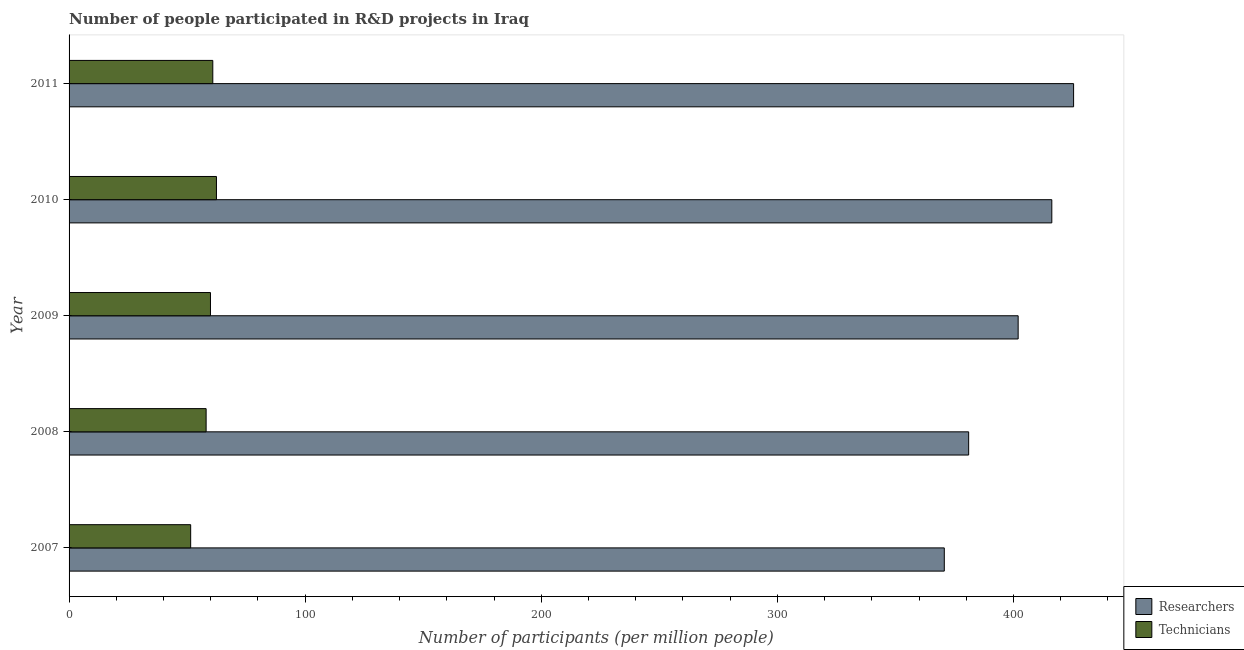How many groups of bars are there?
Provide a succinct answer. 5. How many bars are there on the 5th tick from the bottom?
Your answer should be very brief. 2. In how many cases, is the number of bars for a given year not equal to the number of legend labels?
Make the answer very short. 0. What is the number of researchers in 2009?
Your answer should be compact. 401.99. Across all years, what is the maximum number of researchers?
Your answer should be compact. 425.48. Across all years, what is the minimum number of researchers?
Make the answer very short. 370.71. In which year was the number of researchers maximum?
Provide a succinct answer. 2011. What is the total number of researchers in the graph?
Provide a short and direct response. 1995.47. What is the difference between the number of technicians in 2008 and that in 2010?
Keep it short and to the point. -4.37. What is the difference between the number of technicians in 2011 and the number of researchers in 2010?
Ensure brevity in your answer.  -355.38. What is the average number of technicians per year?
Offer a very short reply. 58.55. In the year 2008, what is the difference between the number of researchers and number of technicians?
Provide a succinct answer. 322.97. In how many years, is the number of researchers greater than 380 ?
Offer a terse response. 4. What is the ratio of the number of technicians in 2007 to that in 2008?
Your response must be concise. 0.89. Is the number of researchers in 2008 less than that in 2011?
Offer a terse response. Yes. Is the difference between the number of researchers in 2008 and 2009 greater than the difference between the number of technicians in 2008 and 2009?
Ensure brevity in your answer.  No. What is the difference between the highest and the second highest number of researchers?
Offer a very short reply. 9.22. What is the difference between the highest and the lowest number of technicians?
Give a very brief answer. 10.92. In how many years, is the number of technicians greater than the average number of technicians taken over all years?
Make the answer very short. 3. What does the 2nd bar from the top in 2009 represents?
Keep it short and to the point. Researchers. What does the 2nd bar from the bottom in 2011 represents?
Provide a succinct answer. Technicians. How many bars are there?
Your answer should be compact. 10. Are all the bars in the graph horizontal?
Offer a very short reply. Yes. What is the difference between two consecutive major ticks on the X-axis?
Your answer should be very brief. 100. Are the values on the major ticks of X-axis written in scientific E-notation?
Your answer should be compact. No. Does the graph contain any zero values?
Provide a succinct answer. No. How many legend labels are there?
Make the answer very short. 2. What is the title of the graph?
Give a very brief answer. Number of people participated in R&D projects in Iraq. Does "RDB concessional" appear as one of the legend labels in the graph?
Provide a succinct answer. No. What is the label or title of the X-axis?
Give a very brief answer. Number of participants (per million people). What is the label or title of the Y-axis?
Make the answer very short. Year. What is the Number of participants (per million people) in Researchers in 2007?
Keep it short and to the point. 370.71. What is the Number of participants (per million people) of Technicians in 2007?
Provide a succinct answer. 51.51. What is the Number of participants (per million people) in Researchers in 2008?
Offer a terse response. 381.03. What is the Number of participants (per million people) in Technicians in 2008?
Provide a short and direct response. 58.05. What is the Number of participants (per million people) of Researchers in 2009?
Your answer should be very brief. 401.99. What is the Number of participants (per million people) in Technicians in 2009?
Make the answer very short. 59.89. What is the Number of participants (per million people) in Researchers in 2010?
Provide a succinct answer. 416.25. What is the Number of participants (per million people) in Technicians in 2010?
Offer a very short reply. 62.43. What is the Number of participants (per million people) in Researchers in 2011?
Keep it short and to the point. 425.48. What is the Number of participants (per million people) in Technicians in 2011?
Provide a short and direct response. 60.88. Across all years, what is the maximum Number of participants (per million people) in Researchers?
Keep it short and to the point. 425.48. Across all years, what is the maximum Number of participants (per million people) of Technicians?
Make the answer very short. 62.43. Across all years, what is the minimum Number of participants (per million people) in Researchers?
Provide a succinct answer. 370.71. Across all years, what is the minimum Number of participants (per million people) in Technicians?
Your answer should be very brief. 51.51. What is the total Number of participants (per million people) of Researchers in the graph?
Give a very brief answer. 1995.47. What is the total Number of participants (per million people) in Technicians in the graph?
Your answer should be compact. 292.75. What is the difference between the Number of participants (per million people) in Researchers in 2007 and that in 2008?
Provide a short and direct response. -10.31. What is the difference between the Number of participants (per million people) in Technicians in 2007 and that in 2008?
Keep it short and to the point. -6.55. What is the difference between the Number of participants (per million people) of Researchers in 2007 and that in 2009?
Offer a very short reply. -31.28. What is the difference between the Number of participants (per million people) in Technicians in 2007 and that in 2009?
Offer a very short reply. -8.39. What is the difference between the Number of participants (per million people) of Researchers in 2007 and that in 2010?
Give a very brief answer. -45.54. What is the difference between the Number of participants (per million people) of Technicians in 2007 and that in 2010?
Ensure brevity in your answer.  -10.92. What is the difference between the Number of participants (per million people) in Researchers in 2007 and that in 2011?
Offer a terse response. -54.76. What is the difference between the Number of participants (per million people) in Technicians in 2007 and that in 2011?
Keep it short and to the point. -9.37. What is the difference between the Number of participants (per million people) in Researchers in 2008 and that in 2009?
Provide a succinct answer. -20.97. What is the difference between the Number of participants (per million people) in Technicians in 2008 and that in 2009?
Provide a succinct answer. -1.84. What is the difference between the Number of participants (per million people) of Researchers in 2008 and that in 2010?
Your answer should be compact. -35.23. What is the difference between the Number of participants (per million people) in Technicians in 2008 and that in 2010?
Give a very brief answer. -4.37. What is the difference between the Number of participants (per million people) of Researchers in 2008 and that in 2011?
Ensure brevity in your answer.  -44.45. What is the difference between the Number of participants (per million people) in Technicians in 2008 and that in 2011?
Provide a short and direct response. -2.82. What is the difference between the Number of participants (per million people) in Researchers in 2009 and that in 2010?
Your answer should be compact. -14.26. What is the difference between the Number of participants (per million people) in Technicians in 2009 and that in 2010?
Provide a short and direct response. -2.53. What is the difference between the Number of participants (per million people) in Researchers in 2009 and that in 2011?
Give a very brief answer. -23.48. What is the difference between the Number of participants (per million people) in Technicians in 2009 and that in 2011?
Provide a short and direct response. -0.98. What is the difference between the Number of participants (per million people) in Researchers in 2010 and that in 2011?
Offer a very short reply. -9.22. What is the difference between the Number of participants (per million people) of Technicians in 2010 and that in 2011?
Make the answer very short. 1.55. What is the difference between the Number of participants (per million people) of Researchers in 2007 and the Number of participants (per million people) of Technicians in 2008?
Your response must be concise. 312.66. What is the difference between the Number of participants (per million people) in Researchers in 2007 and the Number of participants (per million people) in Technicians in 2009?
Offer a terse response. 310.82. What is the difference between the Number of participants (per million people) of Researchers in 2007 and the Number of participants (per million people) of Technicians in 2010?
Your response must be concise. 308.29. What is the difference between the Number of participants (per million people) in Researchers in 2007 and the Number of participants (per million people) in Technicians in 2011?
Your answer should be compact. 309.84. What is the difference between the Number of participants (per million people) in Researchers in 2008 and the Number of participants (per million people) in Technicians in 2009?
Offer a very short reply. 321.13. What is the difference between the Number of participants (per million people) in Researchers in 2008 and the Number of participants (per million people) in Technicians in 2010?
Ensure brevity in your answer.  318.6. What is the difference between the Number of participants (per million people) of Researchers in 2008 and the Number of participants (per million people) of Technicians in 2011?
Your response must be concise. 320.15. What is the difference between the Number of participants (per million people) of Researchers in 2009 and the Number of participants (per million people) of Technicians in 2010?
Offer a terse response. 339.57. What is the difference between the Number of participants (per million people) of Researchers in 2009 and the Number of participants (per million people) of Technicians in 2011?
Provide a succinct answer. 341.12. What is the difference between the Number of participants (per million people) in Researchers in 2010 and the Number of participants (per million people) in Technicians in 2011?
Keep it short and to the point. 355.38. What is the average Number of participants (per million people) of Researchers per year?
Your answer should be very brief. 399.09. What is the average Number of participants (per million people) of Technicians per year?
Make the answer very short. 58.55. In the year 2007, what is the difference between the Number of participants (per million people) in Researchers and Number of participants (per million people) in Technicians?
Your answer should be very brief. 319.21. In the year 2008, what is the difference between the Number of participants (per million people) of Researchers and Number of participants (per million people) of Technicians?
Offer a very short reply. 322.97. In the year 2009, what is the difference between the Number of participants (per million people) of Researchers and Number of participants (per million people) of Technicians?
Your answer should be very brief. 342.1. In the year 2010, what is the difference between the Number of participants (per million people) in Researchers and Number of participants (per million people) in Technicians?
Keep it short and to the point. 353.83. In the year 2011, what is the difference between the Number of participants (per million people) in Researchers and Number of participants (per million people) in Technicians?
Your answer should be very brief. 364.6. What is the ratio of the Number of participants (per million people) of Researchers in 2007 to that in 2008?
Your answer should be compact. 0.97. What is the ratio of the Number of participants (per million people) of Technicians in 2007 to that in 2008?
Your answer should be compact. 0.89. What is the ratio of the Number of participants (per million people) of Researchers in 2007 to that in 2009?
Give a very brief answer. 0.92. What is the ratio of the Number of participants (per million people) of Technicians in 2007 to that in 2009?
Make the answer very short. 0.86. What is the ratio of the Number of participants (per million people) of Researchers in 2007 to that in 2010?
Offer a terse response. 0.89. What is the ratio of the Number of participants (per million people) of Technicians in 2007 to that in 2010?
Make the answer very short. 0.83. What is the ratio of the Number of participants (per million people) of Researchers in 2007 to that in 2011?
Your response must be concise. 0.87. What is the ratio of the Number of participants (per million people) in Technicians in 2007 to that in 2011?
Make the answer very short. 0.85. What is the ratio of the Number of participants (per million people) of Researchers in 2008 to that in 2009?
Your answer should be compact. 0.95. What is the ratio of the Number of participants (per million people) in Technicians in 2008 to that in 2009?
Keep it short and to the point. 0.97. What is the ratio of the Number of participants (per million people) in Researchers in 2008 to that in 2010?
Your response must be concise. 0.92. What is the ratio of the Number of participants (per million people) of Technicians in 2008 to that in 2010?
Provide a short and direct response. 0.93. What is the ratio of the Number of participants (per million people) of Researchers in 2008 to that in 2011?
Keep it short and to the point. 0.9. What is the ratio of the Number of participants (per million people) in Technicians in 2008 to that in 2011?
Offer a very short reply. 0.95. What is the ratio of the Number of participants (per million people) in Researchers in 2009 to that in 2010?
Give a very brief answer. 0.97. What is the ratio of the Number of participants (per million people) of Technicians in 2009 to that in 2010?
Keep it short and to the point. 0.96. What is the ratio of the Number of participants (per million people) of Researchers in 2009 to that in 2011?
Offer a terse response. 0.94. What is the ratio of the Number of participants (per million people) in Technicians in 2009 to that in 2011?
Provide a succinct answer. 0.98. What is the ratio of the Number of participants (per million people) of Researchers in 2010 to that in 2011?
Provide a short and direct response. 0.98. What is the ratio of the Number of participants (per million people) in Technicians in 2010 to that in 2011?
Provide a short and direct response. 1.03. What is the difference between the highest and the second highest Number of participants (per million people) of Researchers?
Your response must be concise. 9.22. What is the difference between the highest and the second highest Number of participants (per million people) of Technicians?
Provide a succinct answer. 1.55. What is the difference between the highest and the lowest Number of participants (per million people) of Researchers?
Provide a short and direct response. 54.76. What is the difference between the highest and the lowest Number of participants (per million people) of Technicians?
Keep it short and to the point. 10.92. 